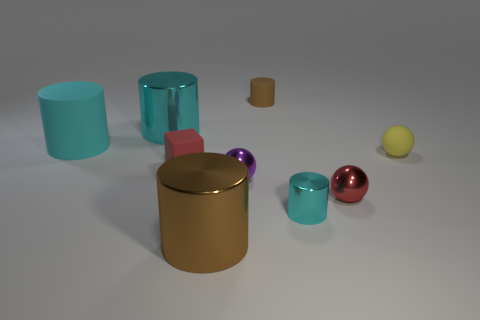Subtract all yellow blocks. How many cyan cylinders are left? 3 Subtract all tiny rubber cylinders. How many cylinders are left? 4 Subtract all red cylinders. Subtract all cyan blocks. How many cylinders are left? 5 Add 1 cyan things. How many objects exist? 10 Subtract all blocks. How many objects are left? 8 Subtract 1 red cubes. How many objects are left? 8 Subtract all large gray matte spheres. Subtract all brown matte things. How many objects are left? 8 Add 6 balls. How many balls are left? 9 Add 5 purple shiny things. How many purple shiny things exist? 6 